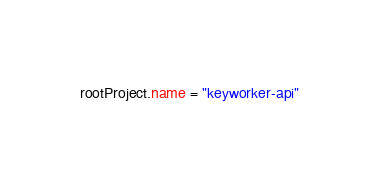<code> <loc_0><loc_0><loc_500><loc_500><_Kotlin_>rootProject.name = "keyworker-api"
</code> 